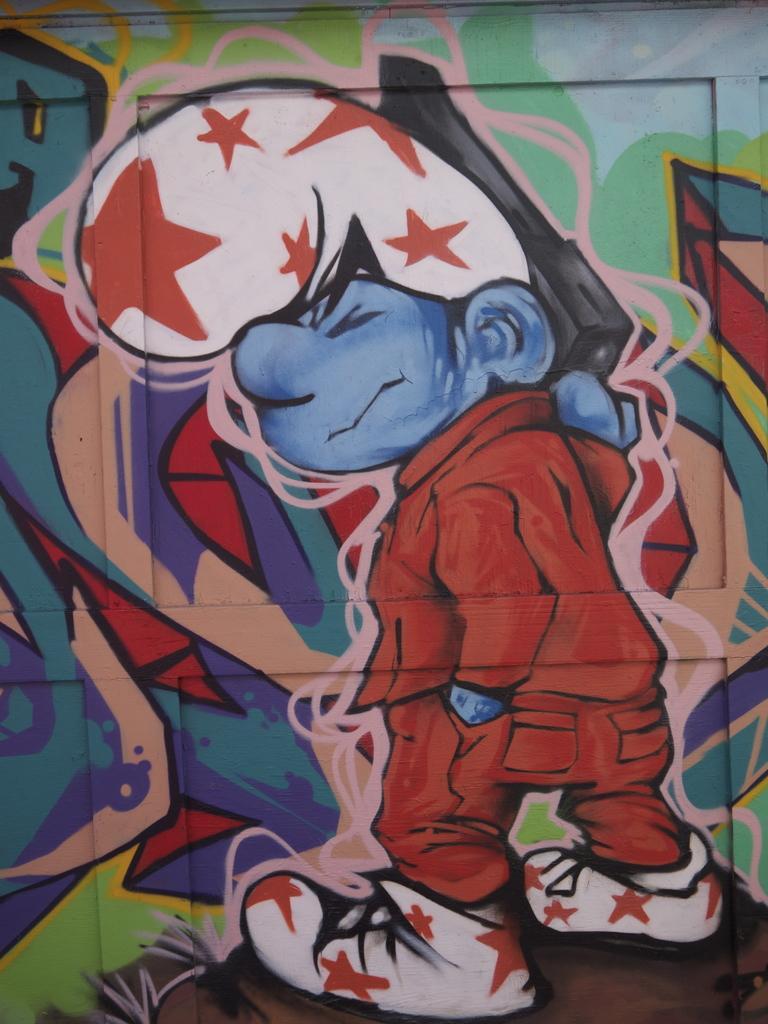Please provide a concise description of this image. In this picture we can see the painting of a smurf and some design on an object. 